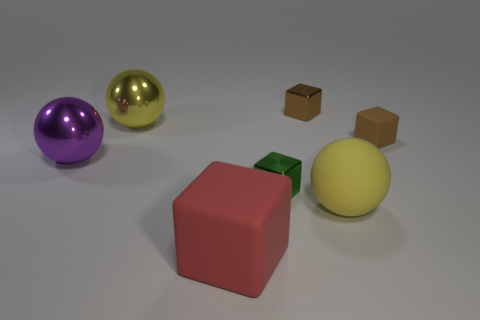There is a large matte ball; does it have the same color as the ball behind the big purple shiny object?
Make the answer very short. Yes. What color is the matte sphere?
Your answer should be very brief. Yellow. The other tiny rubber object that is the same shape as the red object is what color?
Your answer should be very brief. Brown. Do the big purple thing and the tiny brown matte object have the same shape?
Keep it short and to the point. No. How many cylinders are tiny things or large blue matte things?
Offer a very short reply. 0. What is the color of the sphere that is made of the same material as the large cube?
Make the answer very short. Yellow. There is a matte block that is behind the red cube; is its size the same as the matte ball?
Offer a terse response. No. Are the green object and the small brown thing that is behind the tiny brown matte object made of the same material?
Provide a succinct answer. Yes. What color is the ball right of the yellow shiny ball?
Provide a succinct answer. Yellow. Is there a brown matte object to the left of the big matte object that is in front of the yellow rubber ball?
Make the answer very short. No. 